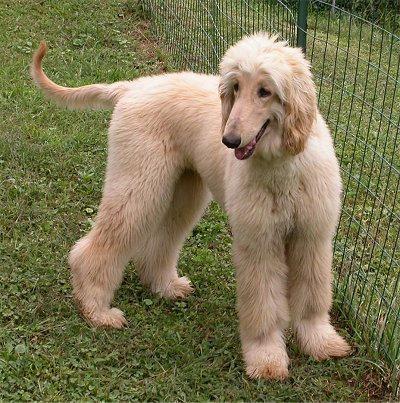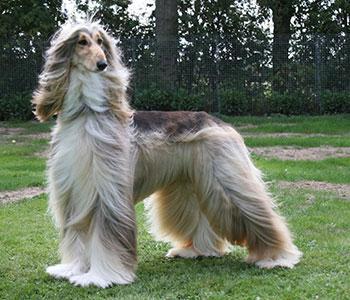The first image is the image on the left, the second image is the image on the right. Assess this claim about the two images: "One dog is looking left and one dog is looking straight ahead.". Correct or not? Answer yes or no. No. 